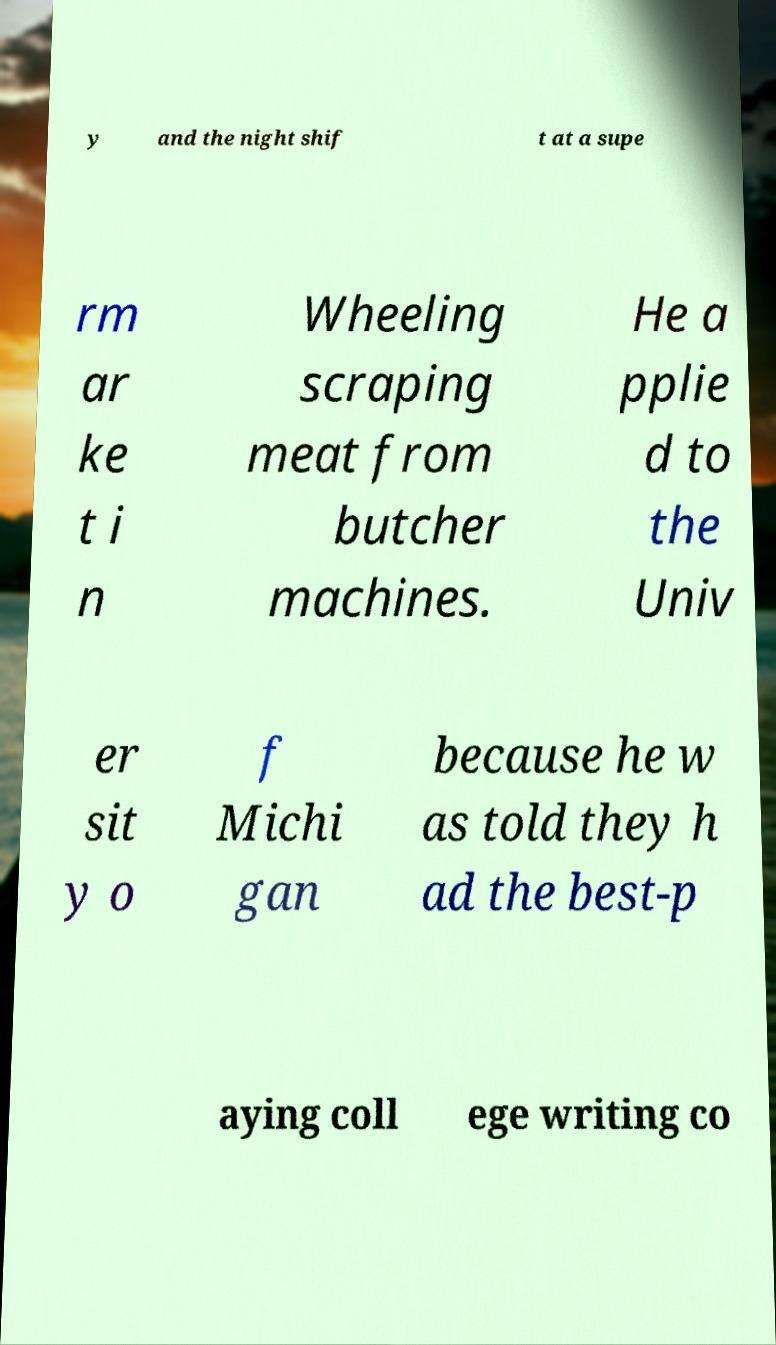Can you accurately transcribe the text from the provided image for me? y and the night shif t at a supe rm ar ke t i n Wheeling scraping meat from butcher machines. He a pplie d to the Univ er sit y o f Michi gan because he w as told they h ad the best-p aying coll ege writing co 